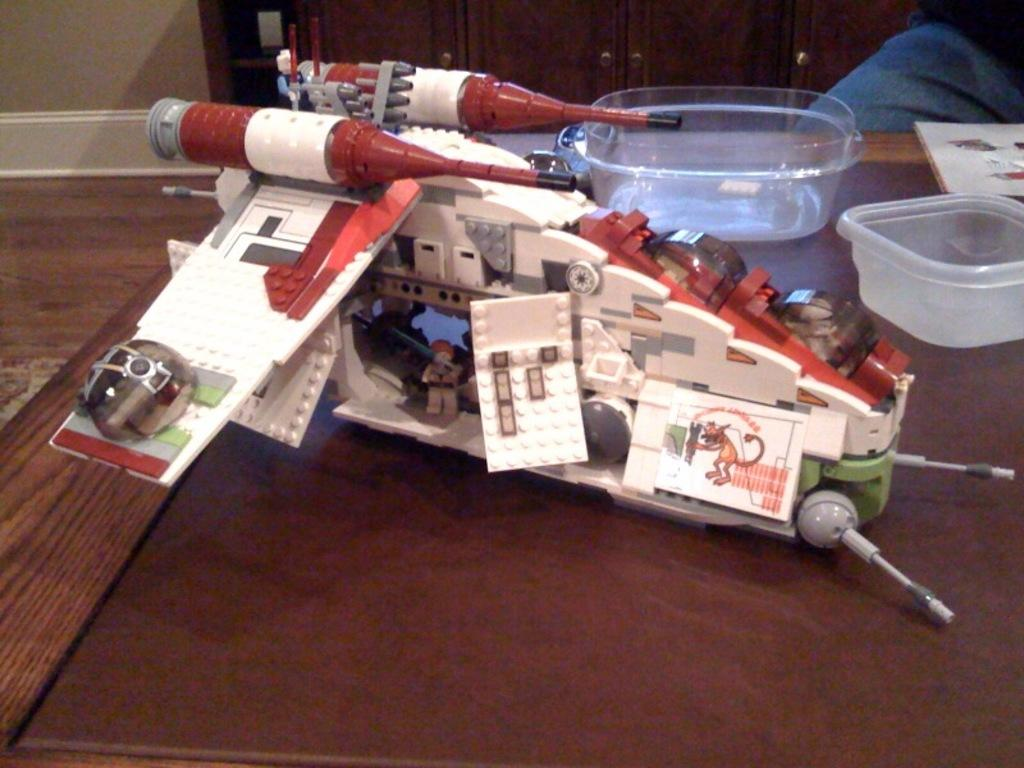What type of object can be seen in the image? There is a toy in the image. What else can be found in the image? There is a book and bowls in the image. What can be seen in the background of the image? There are cupboards and a wall in the background of the image. What type of government is depicted in the image? There is no depiction of a government in the image; it features a toy, a book, bowls, cupboards, and a wall. What is the carpenter doing in the image? There is no carpenter present in the image. 